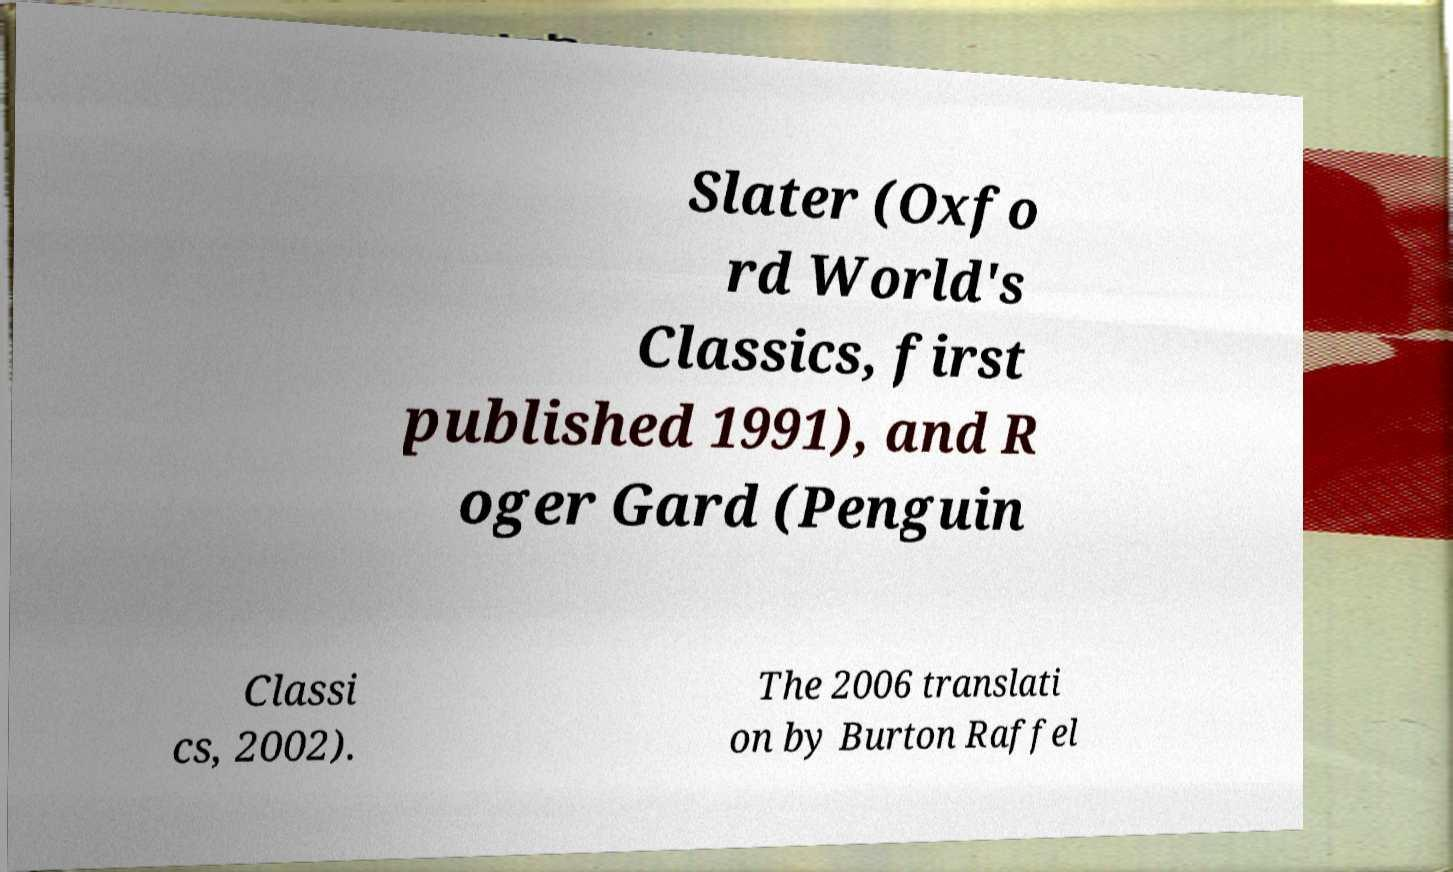Could you extract and type out the text from this image? Slater (Oxfo rd World's Classics, first published 1991), and R oger Gard (Penguin Classi cs, 2002). The 2006 translati on by Burton Raffel 